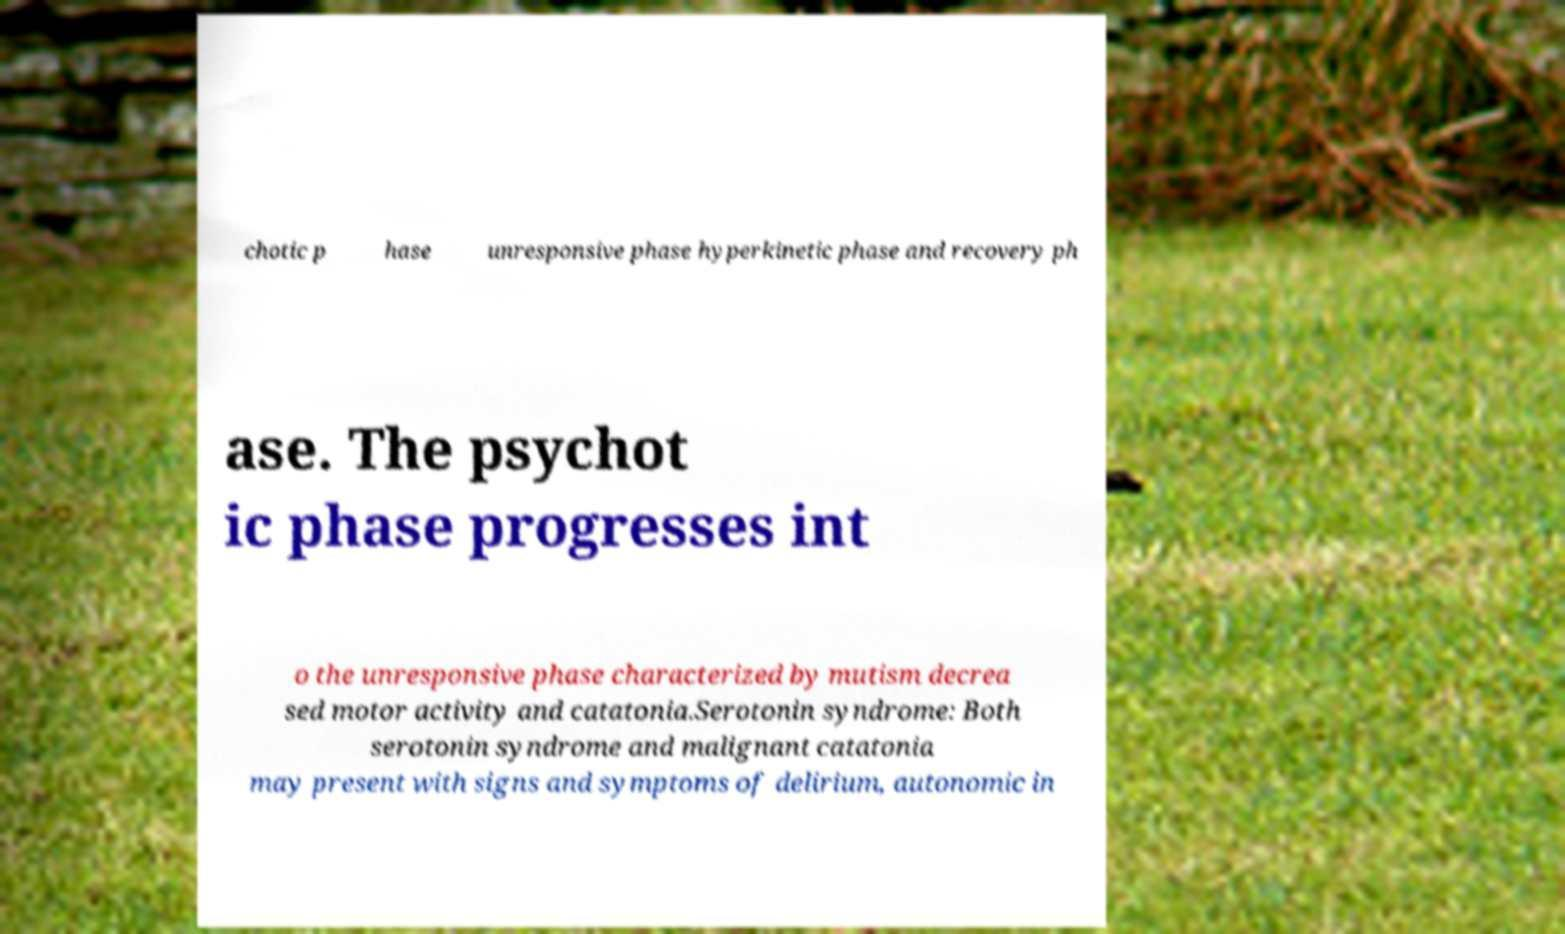Can you read and provide the text displayed in the image?This photo seems to have some interesting text. Can you extract and type it out for me? chotic p hase unresponsive phase hyperkinetic phase and recovery ph ase. The psychot ic phase progresses int o the unresponsive phase characterized by mutism decrea sed motor activity and catatonia.Serotonin syndrome: Both serotonin syndrome and malignant catatonia may present with signs and symptoms of delirium, autonomic in 